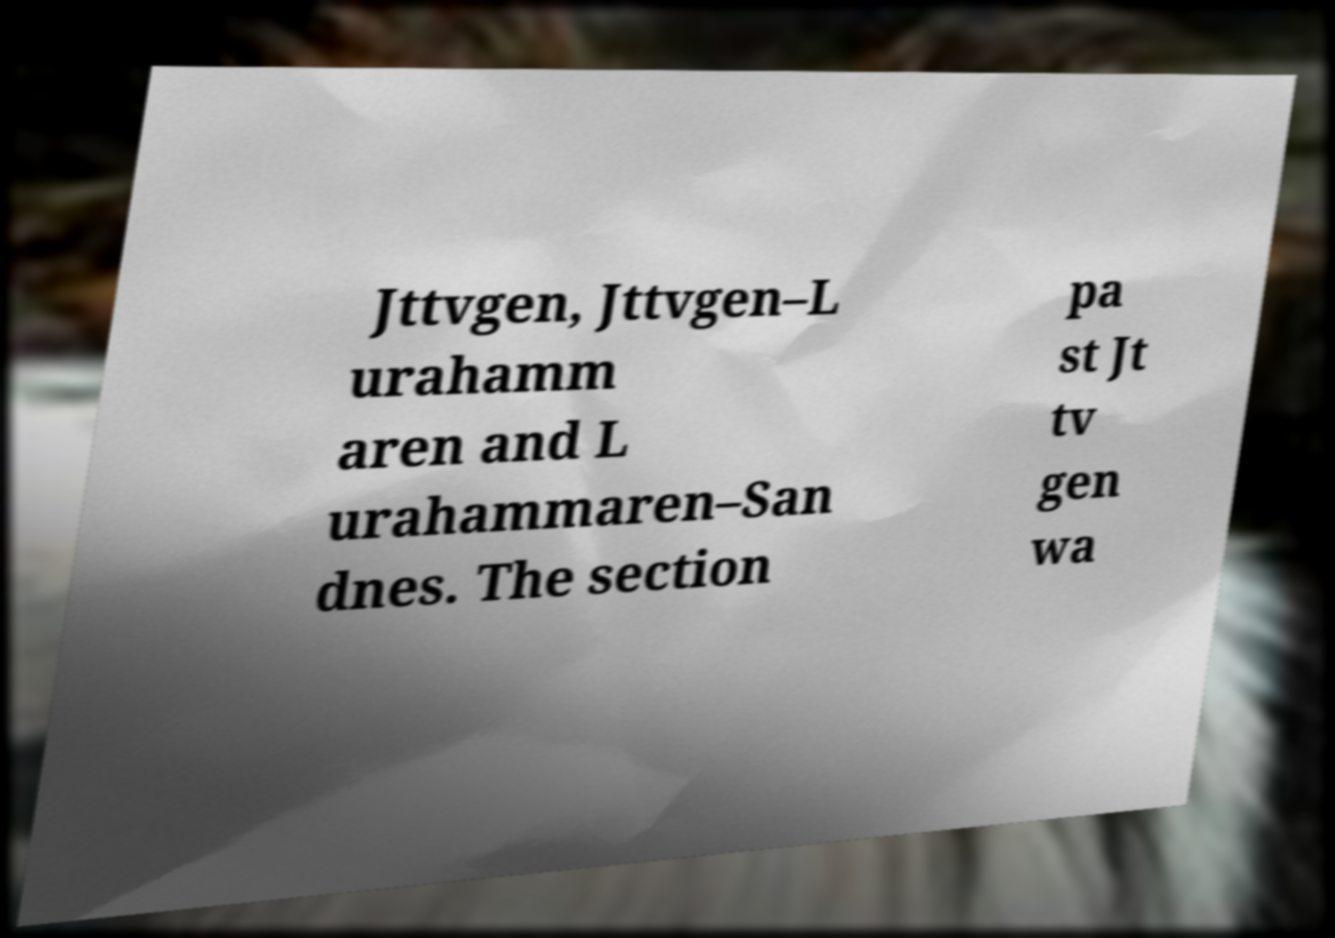Could you extract and type out the text from this image? Jttvgen, Jttvgen–L urahamm aren and L urahammaren–San dnes. The section pa st Jt tv gen wa 